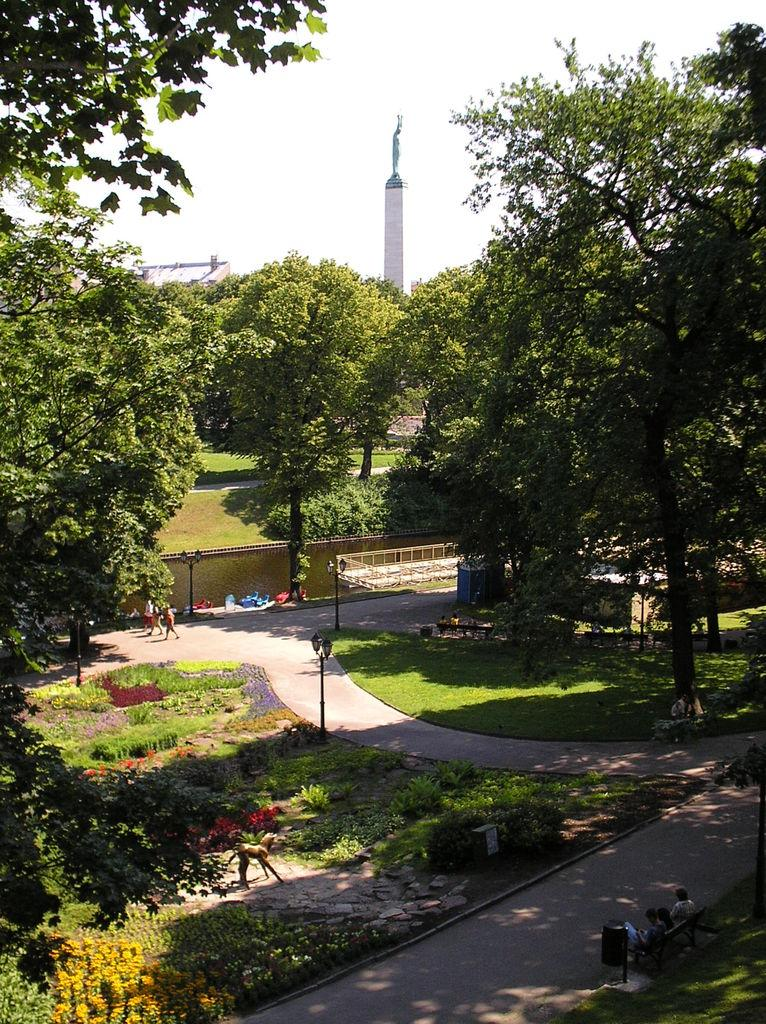What are the people in the image doing? There are persons sitting on a bench in the image. What can be seen in the image besides the people on the bench? There are bins, plants, shrubs, grass, trees, pillars, street poles, street lights, and stones in the image. What type of surface is visible in the image? There is a road in the image. What type of skirt is the gate wearing in the image? There is no gate or skirt present in the image. What material is the steel used for in the image? There is no steel present in the image. 